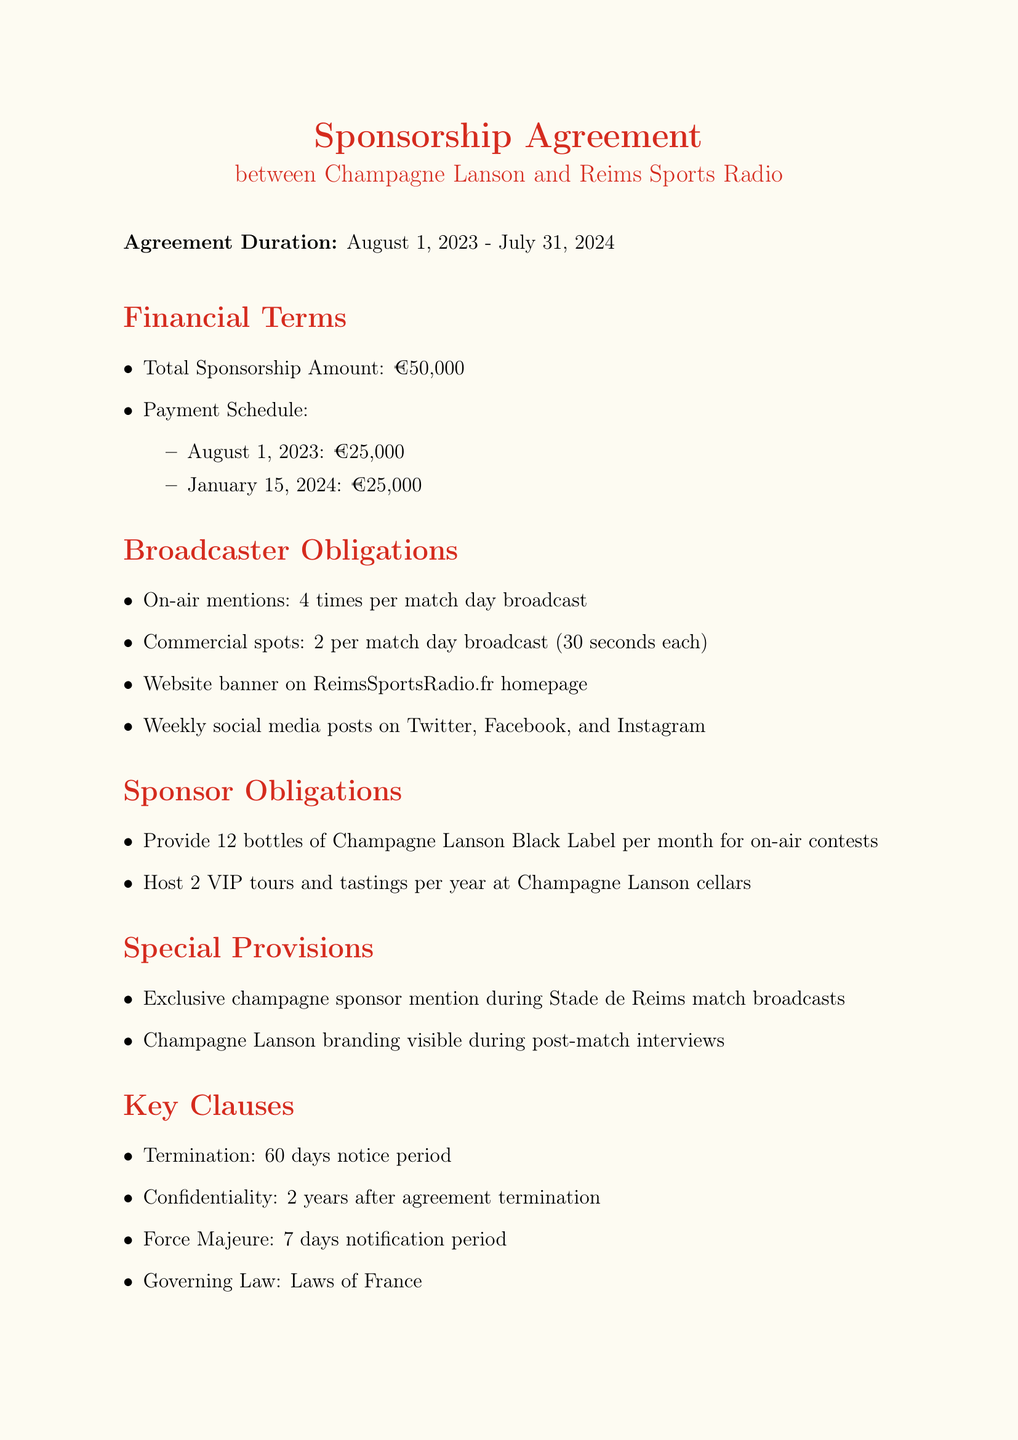What is the total sponsorship amount? The total sponsorship amount is explicitly stated in the financial terms of the document.
Answer: €50,000 When does the sponsorship agreement start? The start date of the agreement is mentioned in the agreement duration section.
Answer: 2023-08-01 Who is the representative for Champagne Lanson? The name and title of the sponsor representative are provided in the signatures section of the document.
Answer: François Roland How many on-air mentions are obligated per match day? The frequency of on-air mentions is specified under broadcaster obligations in the document.
Answer: 4 times What is the notice period for termination? The termination clause specifies the notice period required for ending the agreement.
Answer: 60 days How often will social media posts be made? The frequency of social media posts is outlined in the broadcaster obligations section.
Answer: 1 per week What happens if a party becomes insolvent? This situation is listed as one of the conditions in the termination clause of the document.
Answer: Material breach of agreement What type of event must Champagne Lanson host? The sponsor obligations section details the type of events that Champagne Lanson is responsible for hosting.
Answer: VIP tour and tasting Where will the website banner be placed? The document specifies the location of the website banner under broadcaster obligations.
Answer: Homepage of ReimsSportsRadio.fr 